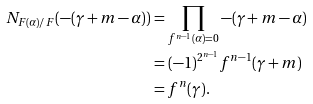Convert formula to latex. <formula><loc_0><loc_0><loc_500><loc_500>N _ { F ( \alpha ) / F } ( - ( \gamma + m - \alpha ) ) & = \prod _ { f ^ { n - 1 } ( \alpha ) = 0 } - ( \gamma + m - \alpha ) \\ & = ( - 1 ) ^ { 2 ^ { n - 1 } } f ^ { n - 1 } ( \gamma + m ) \\ & = f ^ { n } ( \gamma ) .</formula> 